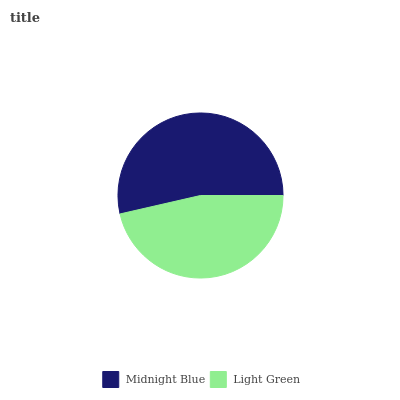Is Light Green the minimum?
Answer yes or no. Yes. Is Midnight Blue the maximum?
Answer yes or no. Yes. Is Light Green the maximum?
Answer yes or no. No. Is Midnight Blue greater than Light Green?
Answer yes or no. Yes. Is Light Green less than Midnight Blue?
Answer yes or no. Yes. Is Light Green greater than Midnight Blue?
Answer yes or no. No. Is Midnight Blue less than Light Green?
Answer yes or no. No. Is Midnight Blue the high median?
Answer yes or no. Yes. Is Light Green the low median?
Answer yes or no. Yes. Is Light Green the high median?
Answer yes or no. No. Is Midnight Blue the low median?
Answer yes or no. No. 